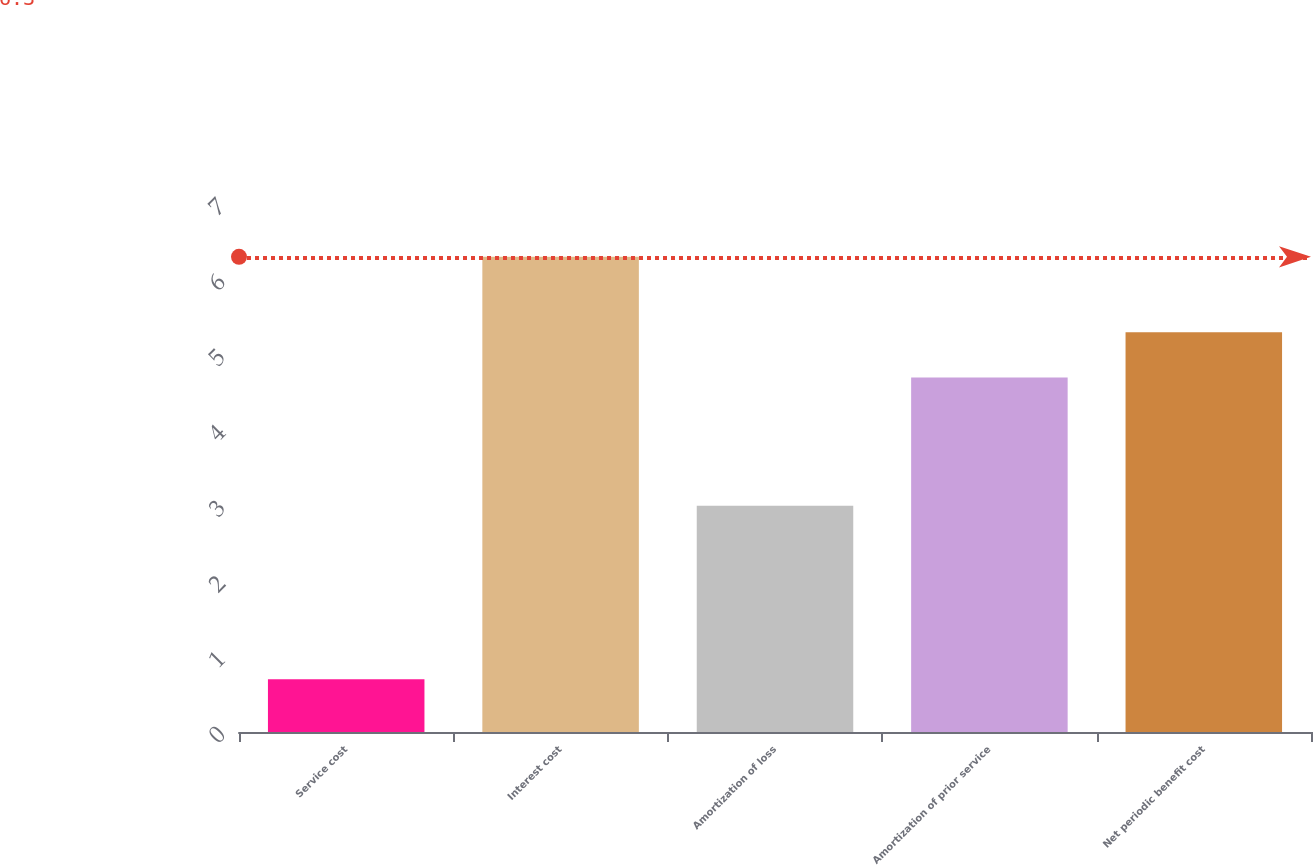Convert chart. <chart><loc_0><loc_0><loc_500><loc_500><bar_chart><fcel>Service cost<fcel>Interest cost<fcel>Amortization of loss<fcel>Amortization of prior service<fcel>Net periodic benefit cost<nl><fcel>0.7<fcel>6.3<fcel>3<fcel>4.7<fcel>5.3<nl></chart> 